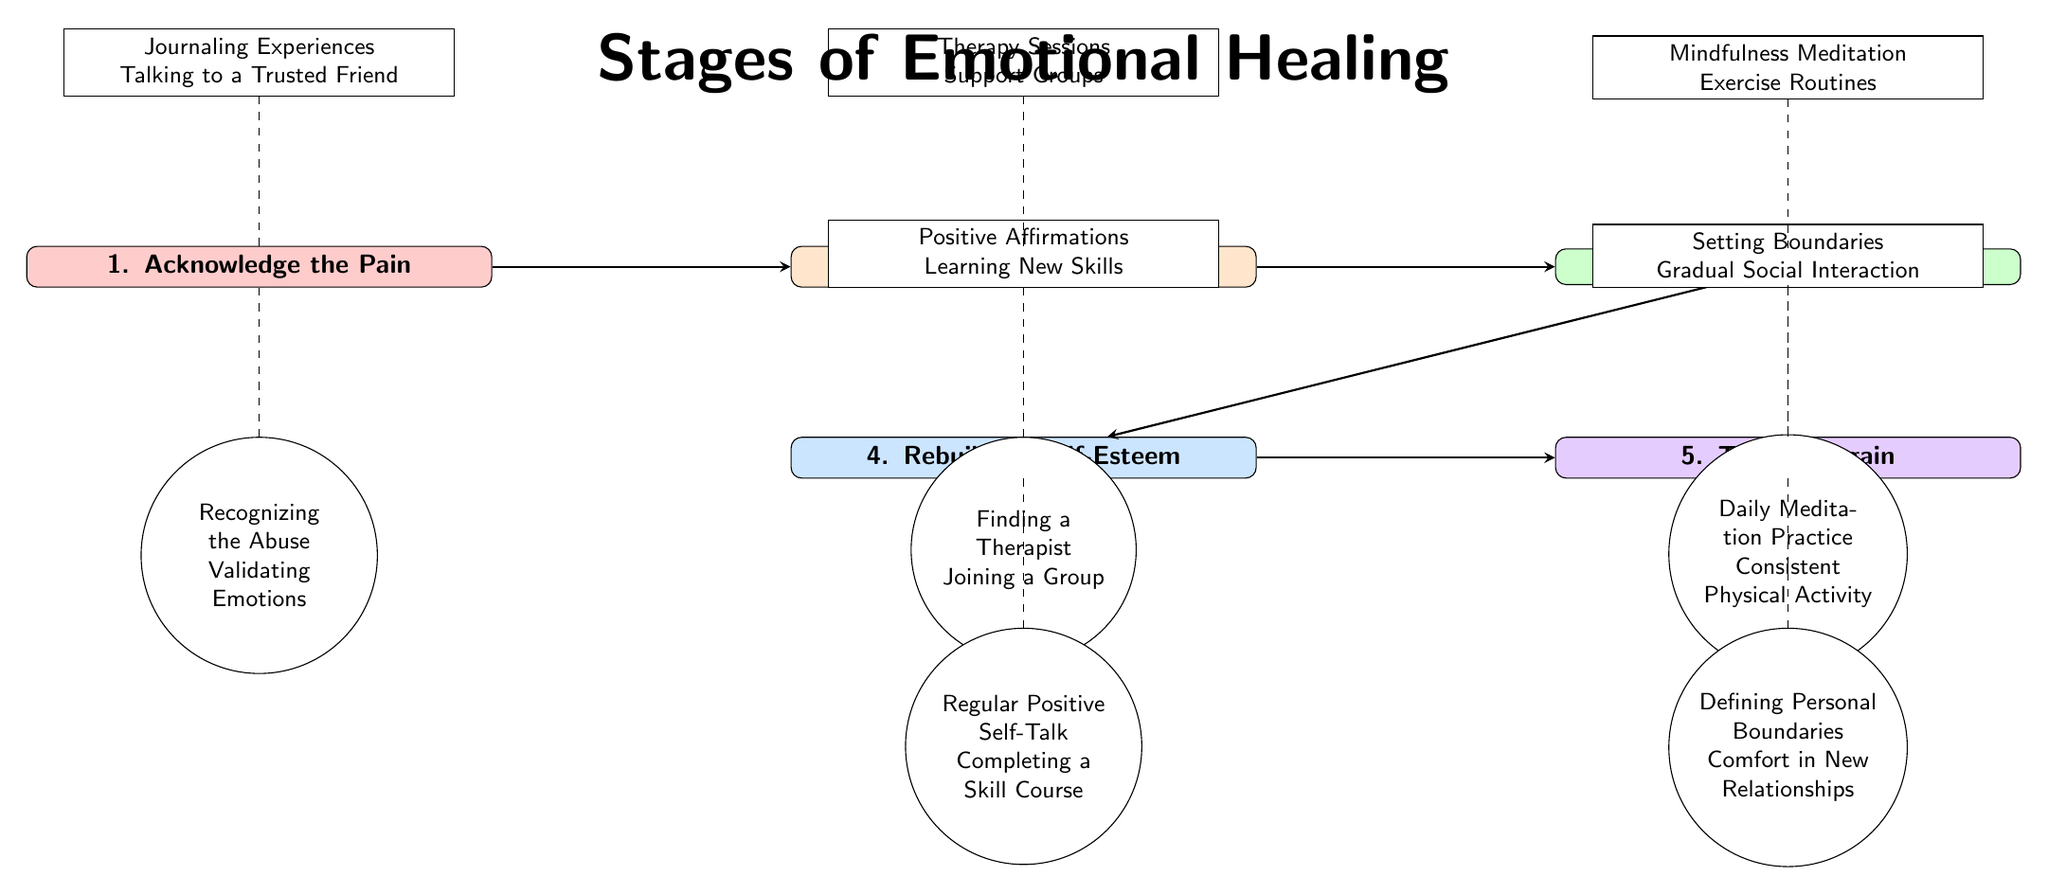What is the first stage of emotional healing? The diagram lists "1. Acknowledge the Pain" as the first stage at the top left.
Answer: Acknowledge the Pain What activity is associated with the second stage? The second stage is "2. Seek Support," and the related activities mentioned above it are "Therapy Sessions" and "Support Groups."
Answer: Therapy Sessions, Support Groups How many stages are represented in the diagram? The diagram shows five distinct stages, numbered from 1 to 5.
Answer: 5 What milestone is related to the third stage? The third stage is "3. Self-Care," with the milestone below it stating "Daily Meditation Practice" and "Consistent Physical Activity."
Answer: Daily Meditation Practice, Consistent Physical Activity What is the last activity listed in the diagram? The final stage "5. Trusting Again" has activities listed above it: "Setting Boundaries" and "Gradual Social Interaction."
Answer: Setting Boundaries, Gradual Social Interaction What is the relationship between "Finding a Therapist" and the second stage? "Finding a Therapist" is labeled as a milestone directly below the second stage "2. Seek Support," indicating it as an important step within this stage.
Answer: Milestone of Seek Support What activities are suggested in the stage before "Trusting Again"? The stage before "Trusting Again" is "4. Rebuilding Self-Esteem," which suggests activities like "Positive Affirmations" and "Learning New Skills" listed above it.
Answer: Positive Affirmations, Learning New Skills What color represents the first stage? The first stage "Acknowledge the Pain" is colored in light red, represented by the RGB value of (255, 204, 204).
Answer: Light red What flow direction is indicated by the arrows in the diagram? The arrows flow from left to right, connecting each stage from "Acknowledge the Pain" to "Trusting Again," depicting the progression through emotional healing stages.
Answer: Left to right 